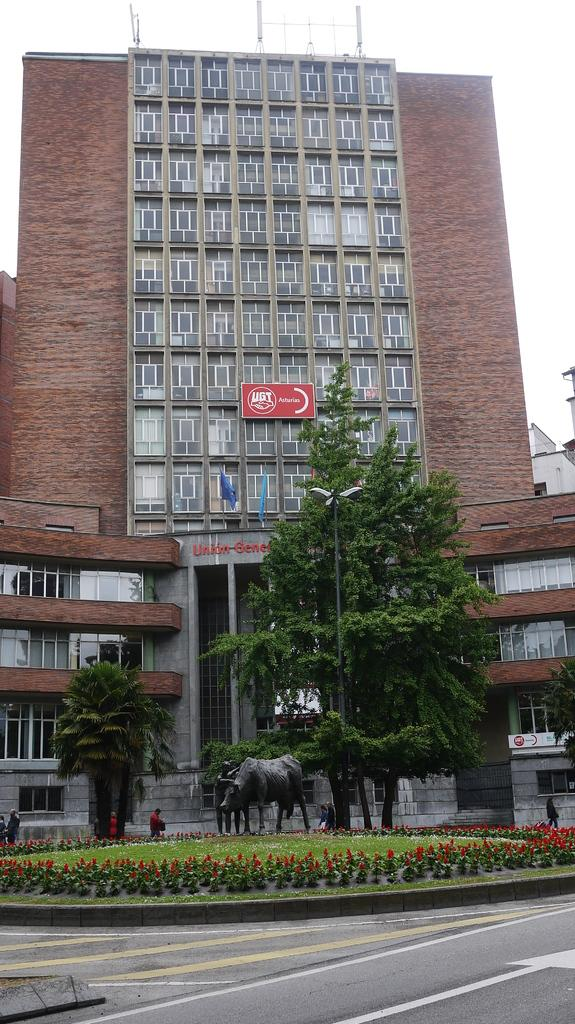What is the color of the building in the image? The building in the image is brown-colored. What type of vegetation is present in the image? There are green trees in the image. What is located in front of the building? There is a statue in front of the building. What color are the flowers in the image? The flowers in the image are red. How many toes are used to water the trees in the image? There are no toes present in the image, and toes are not used to water the trees. 